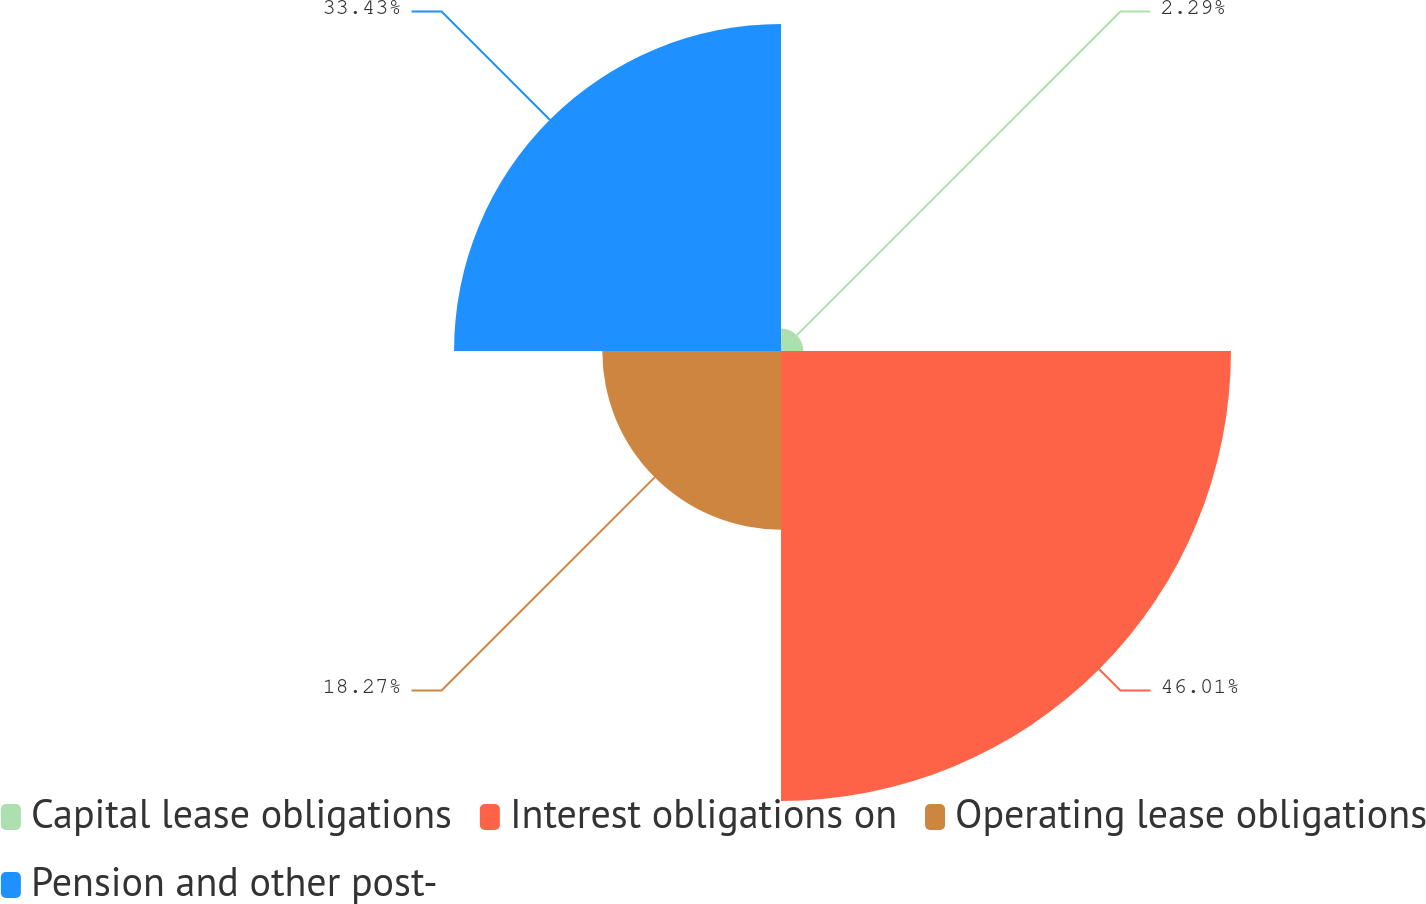Convert chart. <chart><loc_0><loc_0><loc_500><loc_500><pie_chart><fcel>Capital lease obligations<fcel>Interest obligations on<fcel>Operating lease obligations<fcel>Pension and other post-<nl><fcel>2.29%<fcel>46.01%<fcel>18.27%<fcel>33.43%<nl></chart> 